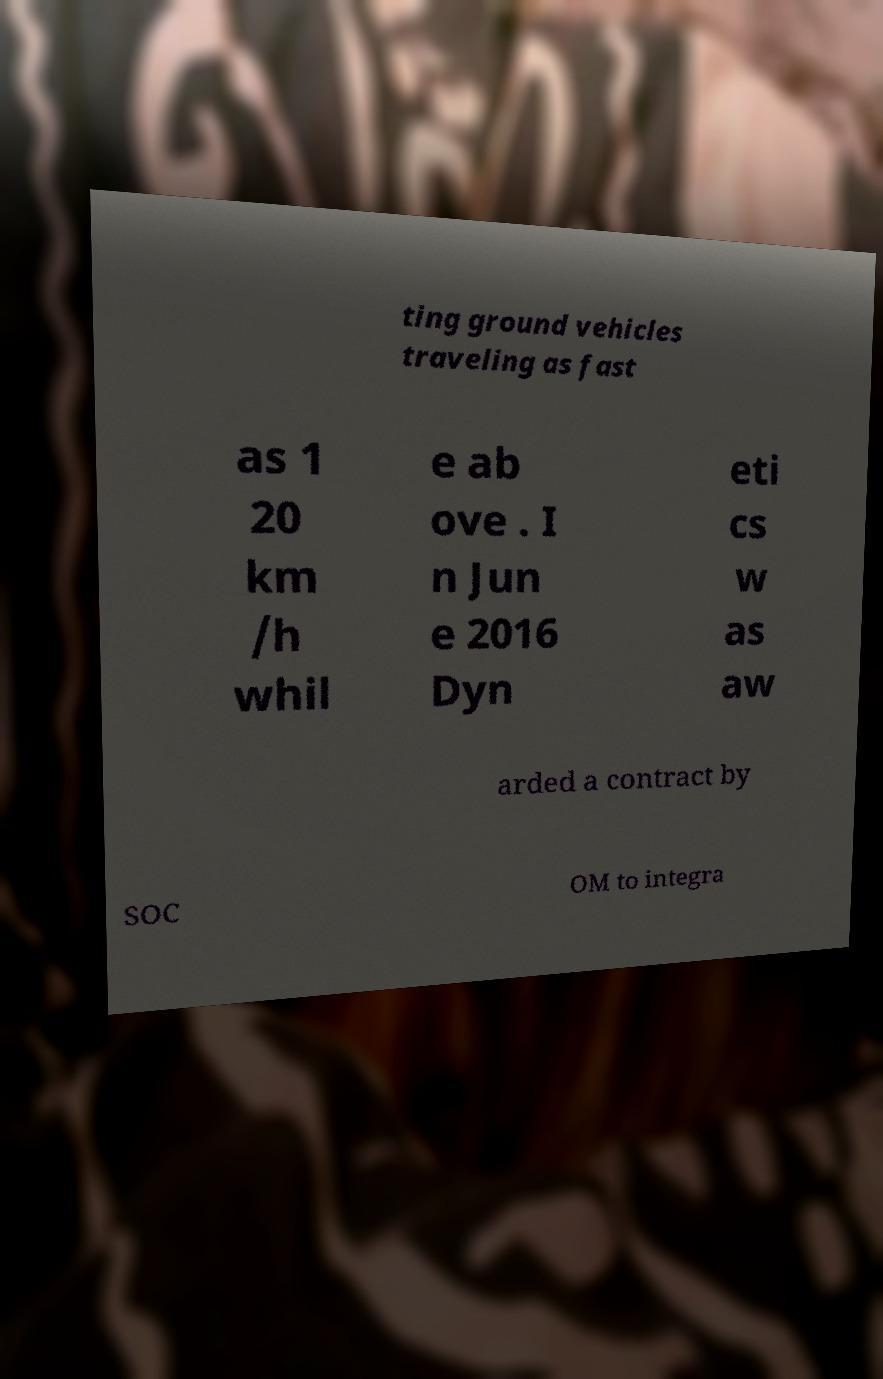There's text embedded in this image that I need extracted. Can you transcribe it verbatim? ting ground vehicles traveling as fast as 1 20 km /h whil e ab ove . I n Jun e 2016 Dyn eti cs w as aw arded a contract by SOC OM to integra 